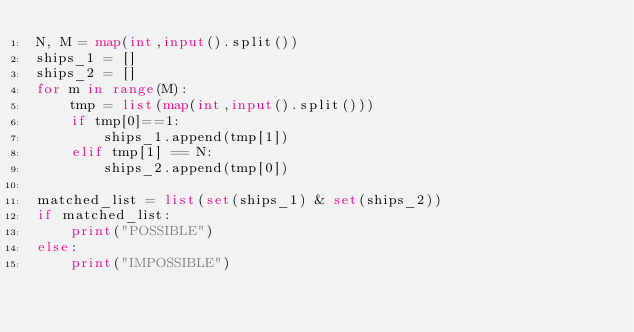Convert code to text. <code><loc_0><loc_0><loc_500><loc_500><_Python_>N, M = map(int,input().split())
ships_1 = []
ships_2 = []
for m in range(M):
    tmp = list(map(int,input().split()))
    if tmp[0]==1:
        ships_1.append(tmp[1])
    elif tmp[1] == N:
        ships_2.append(tmp[0])

matched_list = list(set(ships_1) & set(ships_2))
if matched_list:
    print("POSSIBLE")
else:
    print("IMPOSSIBLE")
</code> 